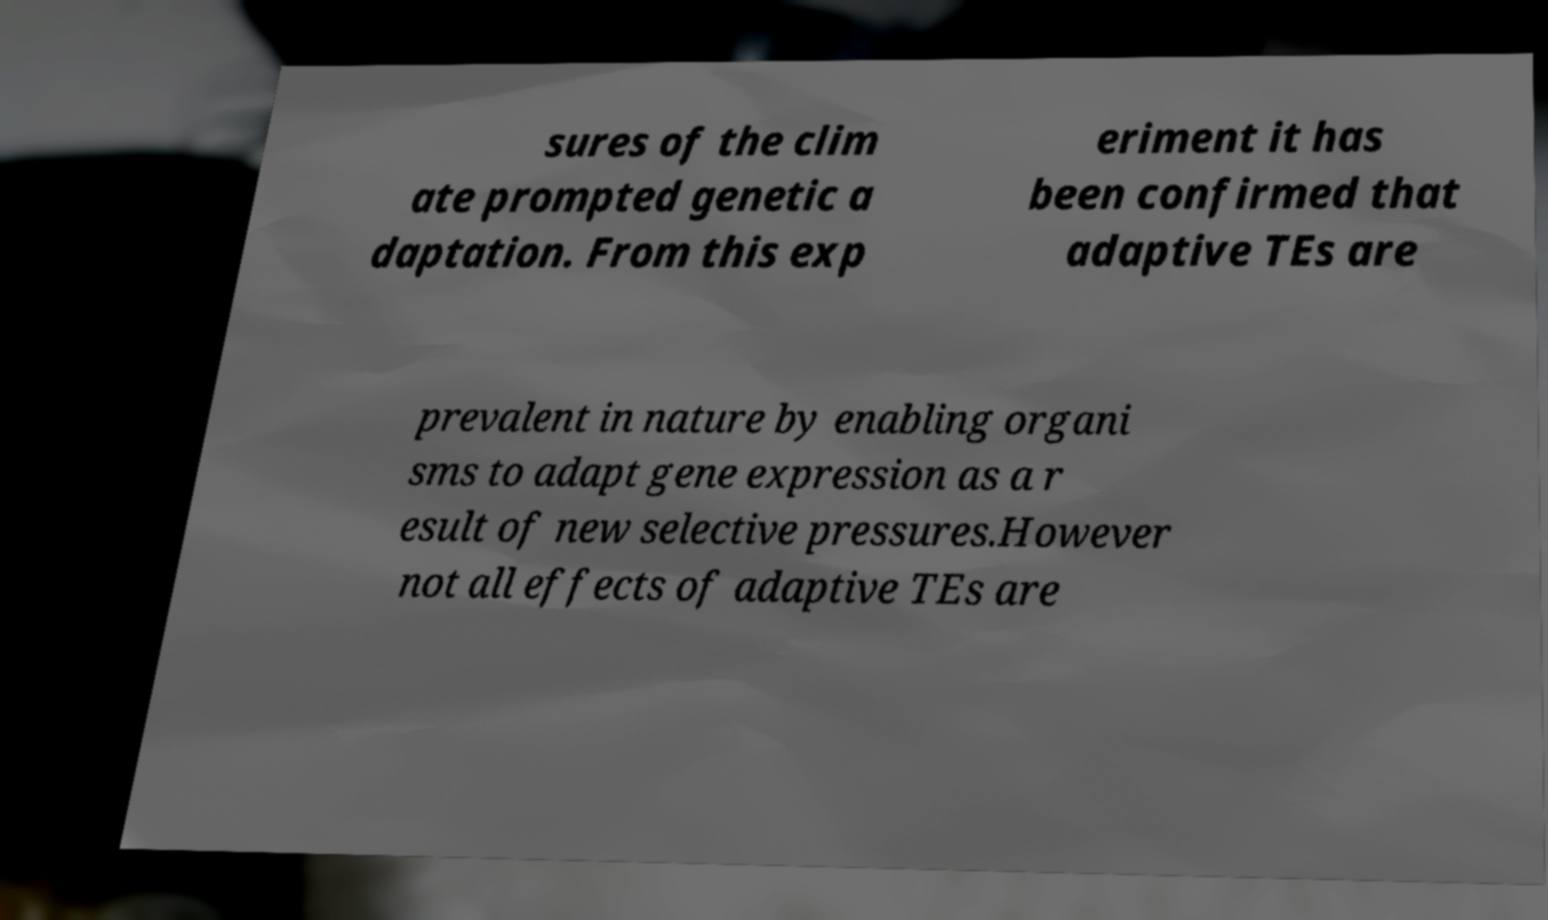Can you read and provide the text displayed in the image?This photo seems to have some interesting text. Can you extract and type it out for me? sures of the clim ate prompted genetic a daptation. From this exp eriment it has been confirmed that adaptive TEs are prevalent in nature by enabling organi sms to adapt gene expression as a r esult of new selective pressures.However not all effects of adaptive TEs are 